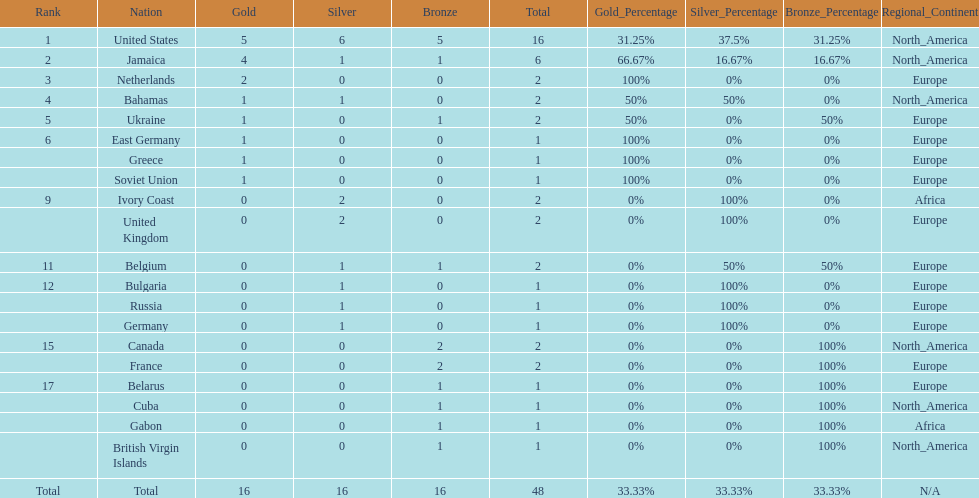How many gold medals did the us and jamaica win combined? 9. 